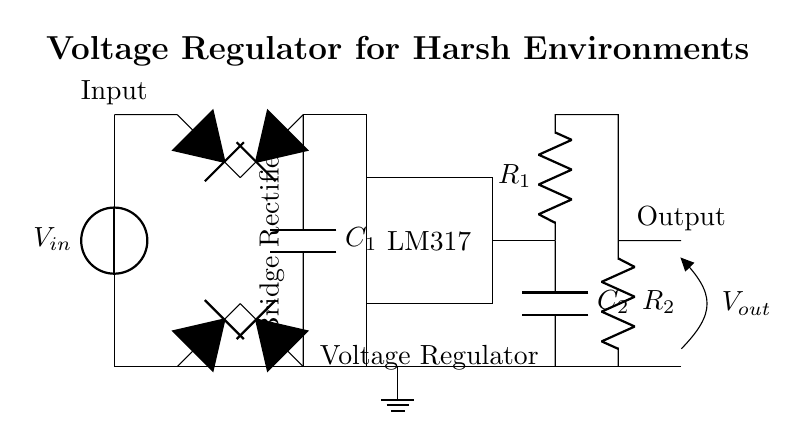What is the type of voltage regulator used in this circuit? The circuit diagram shows an LM317, which is a commonly used adjustable linear voltage regulator. This can be identified from the labeled rectangular section in the diagram.
Answer: LM317 What is the purpose of the diode bridge in the circuit? The diode bridge converts alternating current (AC) input voltage into direct current (DC). This is evident as the bridge rectifier is placed between the input voltage source and the voltage regulator, indicating its role in converting and stabilizing the power supply.
Answer: Rectification How many capacitors are present in this circuit? The circuit includes two capacitors, labeled as C1 and C2. They are crucial for filtering the output voltage and smoothing the fluctuations.
Answer: Two What is the function of the resistors R1 and R2 in this circuit? Resistors R1 and R2 are used to set the output voltage of the LM317 regulator. Their values determine the voltage output based on the voltage divider principle and can be derived from the basic operation of the LM317 as indicated in the circuit design.
Answer: Voltage setting What happens to the voltage if the input voltage exceeds a certain threshold? If the input voltage exceeds the maximum allowable input voltage of the LM317 (which is typically around 40V), it might lead to the destruction of the regulator or overheating. The circuit does not include over-voltage protection, which could lead to failure in harsh environments.
Answer: Possible damage What component connects the input voltage to the voltage regulator? The diode bridge directly connects the input voltage to the voltage regulator, ensuring that the voltage is transformed from AC to a usable DC form, highlighted by the paths leading from the input to the regulator in the diagram.
Answer: Diode bridge What is the significance of placing capacitors before and after the voltage regulator? The capacitors are placed before and after the voltage regulator to filter out noise and stabilize the voltage. C1 smooths the rectified voltage, while C2 provides stability to the output by absorbing ripples, ensuring a steady DC output, which is essential in harsh environments.
Answer: Voltage stabilization 